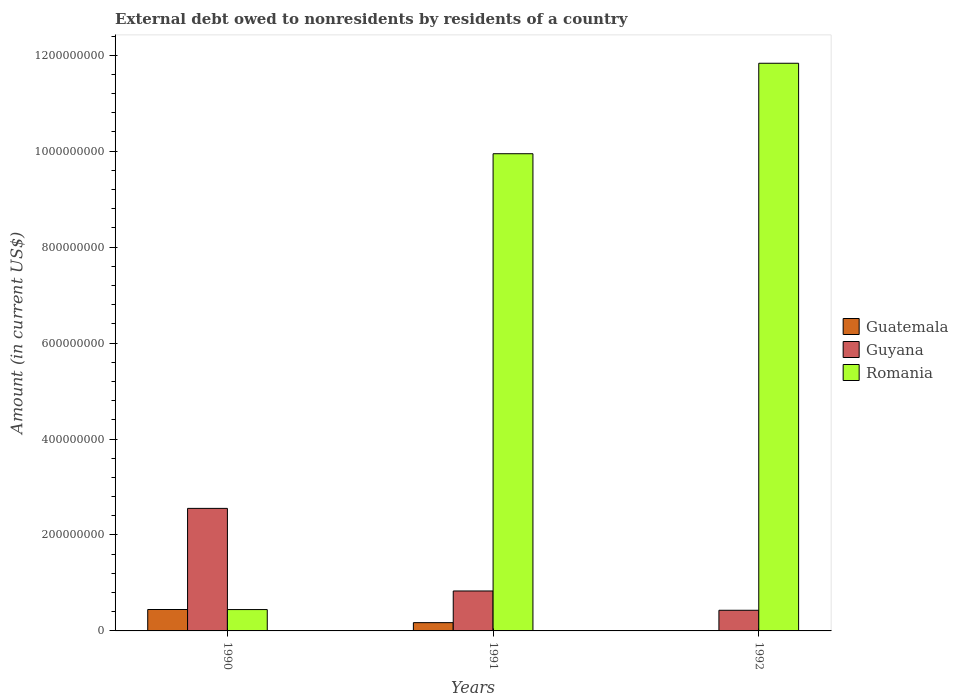How many different coloured bars are there?
Keep it short and to the point. 3. Are the number of bars per tick equal to the number of legend labels?
Provide a succinct answer. No. What is the label of the 2nd group of bars from the left?
Provide a succinct answer. 1991. What is the external debt owed by residents in Guatemala in 1990?
Your answer should be compact. 4.46e+07. Across all years, what is the maximum external debt owed by residents in Guyana?
Provide a short and direct response. 2.55e+08. What is the total external debt owed by residents in Guyana in the graph?
Offer a terse response. 3.82e+08. What is the difference between the external debt owed by residents in Romania in 1990 and that in 1992?
Provide a short and direct response. -1.14e+09. What is the difference between the external debt owed by residents in Guatemala in 1992 and the external debt owed by residents in Romania in 1991?
Your answer should be very brief. -9.95e+08. What is the average external debt owed by residents in Romania per year?
Ensure brevity in your answer.  7.41e+08. In the year 1991, what is the difference between the external debt owed by residents in Guatemala and external debt owed by residents in Guyana?
Provide a succinct answer. -6.60e+07. In how many years, is the external debt owed by residents in Guatemala greater than 480000000 US$?
Provide a succinct answer. 0. What is the ratio of the external debt owed by residents in Guatemala in 1990 to that in 1991?
Provide a short and direct response. 2.59. Is the external debt owed by residents in Guyana in 1990 less than that in 1991?
Your answer should be very brief. No. Is the difference between the external debt owed by residents in Guatemala in 1990 and 1991 greater than the difference between the external debt owed by residents in Guyana in 1990 and 1991?
Offer a terse response. No. What is the difference between the highest and the second highest external debt owed by residents in Romania?
Your answer should be very brief. 1.89e+08. What is the difference between the highest and the lowest external debt owed by residents in Guatemala?
Your response must be concise. 4.46e+07. Is it the case that in every year, the sum of the external debt owed by residents in Romania and external debt owed by residents in Guatemala is greater than the external debt owed by residents in Guyana?
Give a very brief answer. No. How many bars are there?
Offer a terse response. 8. How many years are there in the graph?
Give a very brief answer. 3. Does the graph contain any zero values?
Ensure brevity in your answer.  Yes. Does the graph contain grids?
Offer a terse response. No. How are the legend labels stacked?
Offer a very short reply. Vertical. What is the title of the graph?
Give a very brief answer. External debt owed to nonresidents by residents of a country. Does "Philippines" appear as one of the legend labels in the graph?
Your answer should be compact. No. What is the label or title of the X-axis?
Give a very brief answer. Years. What is the Amount (in current US$) of Guatemala in 1990?
Offer a very short reply. 4.46e+07. What is the Amount (in current US$) in Guyana in 1990?
Give a very brief answer. 2.55e+08. What is the Amount (in current US$) in Romania in 1990?
Your answer should be compact. 4.45e+07. What is the Amount (in current US$) of Guatemala in 1991?
Your answer should be very brief. 1.72e+07. What is the Amount (in current US$) in Guyana in 1991?
Offer a terse response. 8.33e+07. What is the Amount (in current US$) of Romania in 1991?
Provide a short and direct response. 9.95e+08. What is the Amount (in current US$) in Guyana in 1992?
Offer a terse response. 4.30e+07. What is the Amount (in current US$) in Romania in 1992?
Provide a succinct answer. 1.18e+09. Across all years, what is the maximum Amount (in current US$) in Guatemala?
Your answer should be very brief. 4.46e+07. Across all years, what is the maximum Amount (in current US$) of Guyana?
Provide a succinct answer. 2.55e+08. Across all years, what is the maximum Amount (in current US$) of Romania?
Your answer should be very brief. 1.18e+09. Across all years, what is the minimum Amount (in current US$) of Guatemala?
Provide a short and direct response. 0. Across all years, what is the minimum Amount (in current US$) in Guyana?
Make the answer very short. 4.30e+07. Across all years, what is the minimum Amount (in current US$) in Romania?
Make the answer very short. 4.45e+07. What is the total Amount (in current US$) of Guatemala in the graph?
Ensure brevity in your answer.  6.19e+07. What is the total Amount (in current US$) in Guyana in the graph?
Ensure brevity in your answer.  3.82e+08. What is the total Amount (in current US$) in Romania in the graph?
Give a very brief answer. 2.22e+09. What is the difference between the Amount (in current US$) of Guatemala in 1990 and that in 1991?
Give a very brief answer. 2.74e+07. What is the difference between the Amount (in current US$) of Guyana in 1990 and that in 1991?
Provide a short and direct response. 1.72e+08. What is the difference between the Amount (in current US$) in Romania in 1990 and that in 1991?
Your answer should be compact. -9.50e+08. What is the difference between the Amount (in current US$) of Guyana in 1990 and that in 1992?
Give a very brief answer. 2.12e+08. What is the difference between the Amount (in current US$) of Romania in 1990 and that in 1992?
Your answer should be compact. -1.14e+09. What is the difference between the Amount (in current US$) of Guyana in 1991 and that in 1992?
Offer a very short reply. 4.02e+07. What is the difference between the Amount (in current US$) in Romania in 1991 and that in 1992?
Offer a terse response. -1.89e+08. What is the difference between the Amount (in current US$) in Guatemala in 1990 and the Amount (in current US$) in Guyana in 1991?
Make the answer very short. -3.86e+07. What is the difference between the Amount (in current US$) in Guatemala in 1990 and the Amount (in current US$) in Romania in 1991?
Provide a succinct answer. -9.50e+08. What is the difference between the Amount (in current US$) in Guyana in 1990 and the Amount (in current US$) in Romania in 1991?
Keep it short and to the point. -7.39e+08. What is the difference between the Amount (in current US$) in Guatemala in 1990 and the Amount (in current US$) in Guyana in 1992?
Offer a very short reply. 1.58e+06. What is the difference between the Amount (in current US$) in Guatemala in 1990 and the Amount (in current US$) in Romania in 1992?
Make the answer very short. -1.14e+09. What is the difference between the Amount (in current US$) of Guyana in 1990 and the Amount (in current US$) of Romania in 1992?
Make the answer very short. -9.28e+08. What is the difference between the Amount (in current US$) of Guatemala in 1991 and the Amount (in current US$) of Guyana in 1992?
Provide a succinct answer. -2.58e+07. What is the difference between the Amount (in current US$) in Guatemala in 1991 and the Amount (in current US$) in Romania in 1992?
Keep it short and to the point. -1.17e+09. What is the difference between the Amount (in current US$) of Guyana in 1991 and the Amount (in current US$) of Romania in 1992?
Ensure brevity in your answer.  -1.10e+09. What is the average Amount (in current US$) of Guatemala per year?
Offer a very short reply. 2.06e+07. What is the average Amount (in current US$) of Guyana per year?
Give a very brief answer. 1.27e+08. What is the average Amount (in current US$) in Romania per year?
Ensure brevity in your answer.  7.41e+08. In the year 1990, what is the difference between the Amount (in current US$) of Guatemala and Amount (in current US$) of Guyana?
Your answer should be compact. -2.11e+08. In the year 1990, what is the difference between the Amount (in current US$) in Guatemala and Amount (in current US$) in Romania?
Provide a short and direct response. 1.24e+05. In the year 1990, what is the difference between the Amount (in current US$) of Guyana and Amount (in current US$) of Romania?
Your answer should be very brief. 2.11e+08. In the year 1991, what is the difference between the Amount (in current US$) in Guatemala and Amount (in current US$) in Guyana?
Offer a very short reply. -6.60e+07. In the year 1991, what is the difference between the Amount (in current US$) in Guatemala and Amount (in current US$) in Romania?
Make the answer very short. -9.77e+08. In the year 1991, what is the difference between the Amount (in current US$) of Guyana and Amount (in current US$) of Romania?
Provide a short and direct response. -9.11e+08. In the year 1992, what is the difference between the Amount (in current US$) in Guyana and Amount (in current US$) in Romania?
Your answer should be very brief. -1.14e+09. What is the ratio of the Amount (in current US$) in Guatemala in 1990 to that in 1991?
Provide a short and direct response. 2.59. What is the ratio of the Amount (in current US$) of Guyana in 1990 to that in 1991?
Ensure brevity in your answer.  3.07. What is the ratio of the Amount (in current US$) in Romania in 1990 to that in 1991?
Provide a short and direct response. 0.04. What is the ratio of the Amount (in current US$) of Guyana in 1990 to that in 1992?
Provide a short and direct response. 5.93. What is the ratio of the Amount (in current US$) of Romania in 1990 to that in 1992?
Keep it short and to the point. 0.04. What is the ratio of the Amount (in current US$) of Guyana in 1991 to that in 1992?
Provide a succinct answer. 1.93. What is the ratio of the Amount (in current US$) of Romania in 1991 to that in 1992?
Your response must be concise. 0.84. What is the difference between the highest and the second highest Amount (in current US$) of Guyana?
Offer a very short reply. 1.72e+08. What is the difference between the highest and the second highest Amount (in current US$) of Romania?
Offer a terse response. 1.89e+08. What is the difference between the highest and the lowest Amount (in current US$) in Guatemala?
Offer a terse response. 4.46e+07. What is the difference between the highest and the lowest Amount (in current US$) of Guyana?
Keep it short and to the point. 2.12e+08. What is the difference between the highest and the lowest Amount (in current US$) in Romania?
Provide a succinct answer. 1.14e+09. 